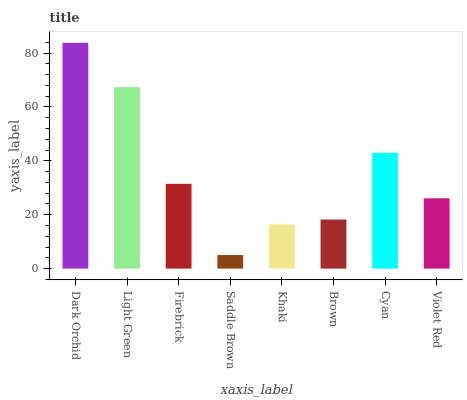Is Light Green the minimum?
Answer yes or no. No. Is Light Green the maximum?
Answer yes or no. No. Is Dark Orchid greater than Light Green?
Answer yes or no. Yes. Is Light Green less than Dark Orchid?
Answer yes or no. Yes. Is Light Green greater than Dark Orchid?
Answer yes or no. No. Is Dark Orchid less than Light Green?
Answer yes or no. No. Is Firebrick the high median?
Answer yes or no. Yes. Is Violet Red the low median?
Answer yes or no. Yes. Is Light Green the high median?
Answer yes or no. No. Is Saddle Brown the low median?
Answer yes or no. No. 